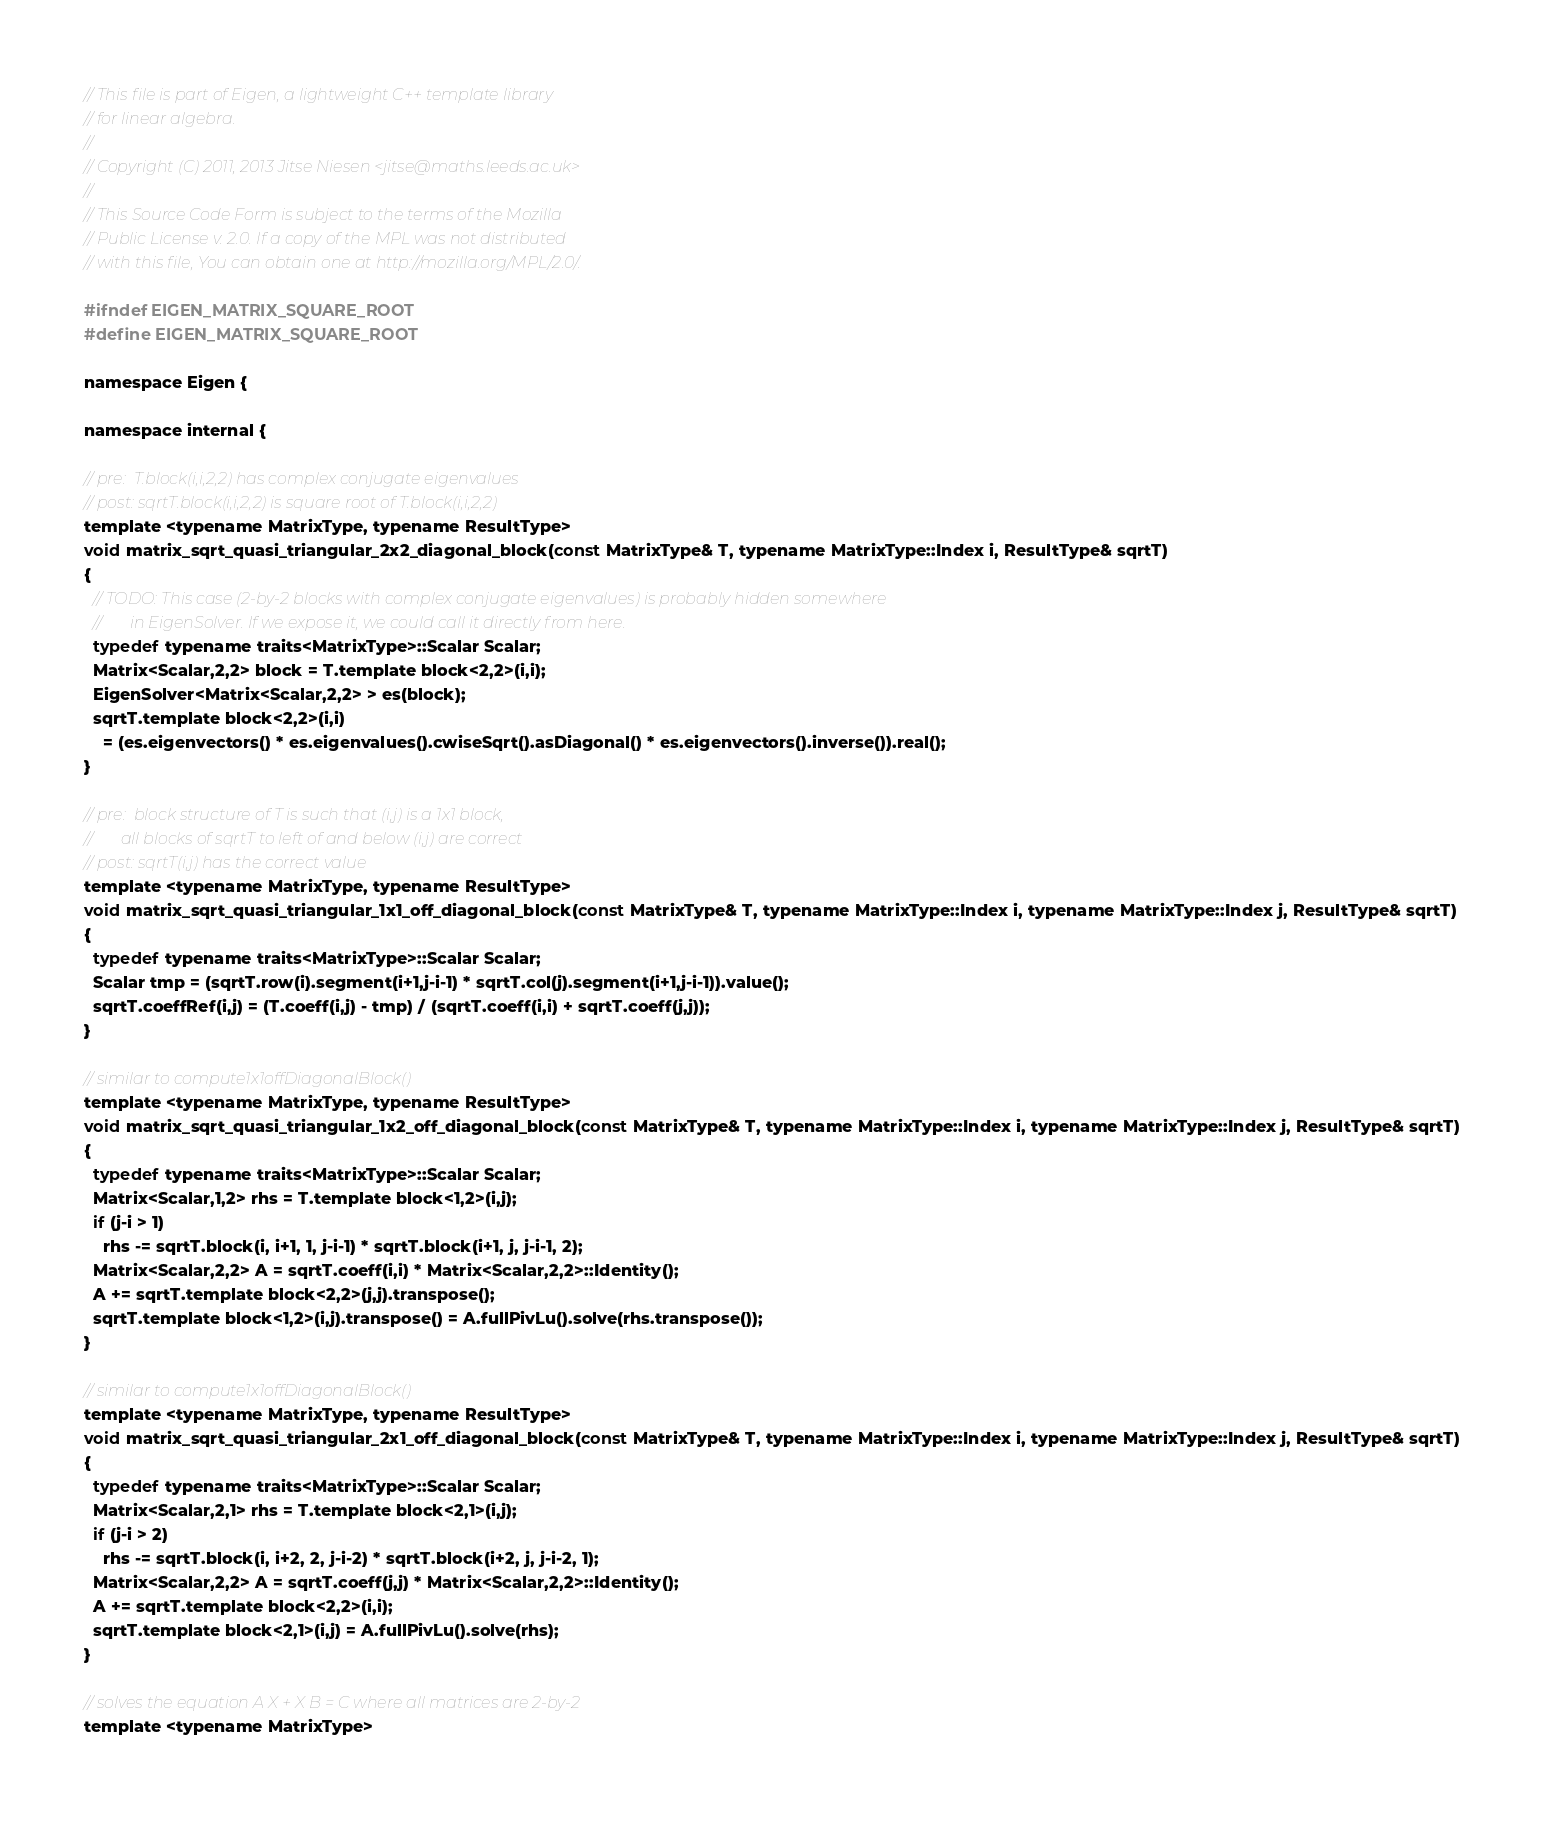<code> <loc_0><loc_0><loc_500><loc_500><_C_>// This file is part of Eigen, a lightweight C++ template library
// for linear algebra.
//
// Copyright (C) 2011, 2013 Jitse Niesen <jitse@maths.leeds.ac.uk>
//
// This Source Code Form is subject to the terms of the Mozilla
// Public License v. 2.0. If a copy of the MPL was not distributed
// with this file, You can obtain one at http://mozilla.org/MPL/2.0/.

#ifndef EIGEN_MATRIX_SQUARE_ROOT
#define EIGEN_MATRIX_SQUARE_ROOT

namespace Eigen { 

namespace internal {

// pre:  T.block(i,i,2,2) has complex conjugate eigenvalues
// post: sqrtT.block(i,i,2,2) is square root of T.block(i,i,2,2)
template <typename MatrixType, typename ResultType>
void matrix_sqrt_quasi_triangular_2x2_diagonal_block(const MatrixType& T, typename MatrixType::Index i, ResultType& sqrtT)
{
  // TODO: This case (2-by-2 blocks with complex conjugate eigenvalues) is probably hidden somewhere
  //       in EigenSolver. If we expose it, we could call it directly from here.
  typedef typename traits<MatrixType>::Scalar Scalar;
  Matrix<Scalar,2,2> block = T.template block<2,2>(i,i);
  EigenSolver<Matrix<Scalar,2,2> > es(block);
  sqrtT.template block<2,2>(i,i)
    = (es.eigenvectors() * es.eigenvalues().cwiseSqrt().asDiagonal() * es.eigenvectors().inverse()).real();
}

// pre:  block structure of T is such that (i,j) is a 1x1 block,
//       all blocks of sqrtT to left of and below (i,j) are correct
// post: sqrtT(i,j) has the correct value
template <typename MatrixType, typename ResultType>
void matrix_sqrt_quasi_triangular_1x1_off_diagonal_block(const MatrixType& T, typename MatrixType::Index i, typename MatrixType::Index j, ResultType& sqrtT)
{
  typedef typename traits<MatrixType>::Scalar Scalar;
  Scalar tmp = (sqrtT.row(i).segment(i+1,j-i-1) * sqrtT.col(j).segment(i+1,j-i-1)).value();
  sqrtT.coeffRef(i,j) = (T.coeff(i,j) - tmp) / (sqrtT.coeff(i,i) + sqrtT.coeff(j,j));
}

// similar to compute1x1offDiagonalBlock()
template <typename MatrixType, typename ResultType>
void matrix_sqrt_quasi_triangular_1x2_off_diagonal_block(const MatrixType& T, typename MatrixType::Index i, typename MatrixType::Index j, ResultType& sqrtT)
{
  typedef typename traits<MatrixType>::Scalar Scalar;
  Matrix<Scalar,1,2> rhs = T.template block<1,2>(i,j);
  if (j-i > 1)
    rhs -= sqrtT.block(i, i+1, 1, j-i-1) * sqrtT.block(i+1, j, j-i-1, 2);
  Matrix<Scalar,2,2> A = sqrtT.coeff(i,i) * Matrix<Scalar,2,2>::Identity();
  A += sqrtT.template block<2,2>(j,j).transpose();
  sqrtT.template block<1,2>(i,j).transpose() = A.fullPivLu().solve(rhs.transpose());
}

// similar to compute1x1offDiagonalBlock()
template <typename MatrixType, typename ResultType>
void matrix_sqrt_quasi_triangular_2x1_off_diagonal_block(const MatrixType& T, typename MatrixType::Index i, typename MatrixType::Index j, ResultType& sqrtT)
{
  typedef typename traits<MatrixType>::Scalar Scalar;
  Matrix<Scalar,2,1> rhs = T.template block<2,1>(i,j);
  if (j-i > 2)
    rhs -= sqrtT.block(i, i+2, 2, j-i-2) * sqrtT.block(i+2, j, j-i-2, 1);
  Matrix<Scalar,2,2> A = sqrtT.coeff(j,j) * Matrix<Scalar,2,2>::Identity();
  A += sqrtT.template block<2,2>(i,i);
  sqrtT.template block<2,1>(i,j) = A.fullPivLu().solve(rhs);
}

// solves the equation A X + X B = C where all matrices are 2-by-2
template <typename MatrixType></code> 